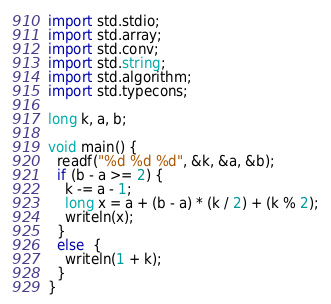<code> <loc_0><loc_0><loc_500><loc_500><_D_>import std.stdio;
import std.array;
import std.conv;
import std.string;
import std.algorithm;
import std.typecons;

long k, a, b;

void main() {
  readf("%d %d %d", &k, &a, &b);
  if (b - a >= 2) {
    k -= a - 1;
    long x = a + (b - a) * (k / 2) + (k % 2);
    writeln(x);
  }
  else  {
    writeln(1 + k);
  }   
}
</code> 